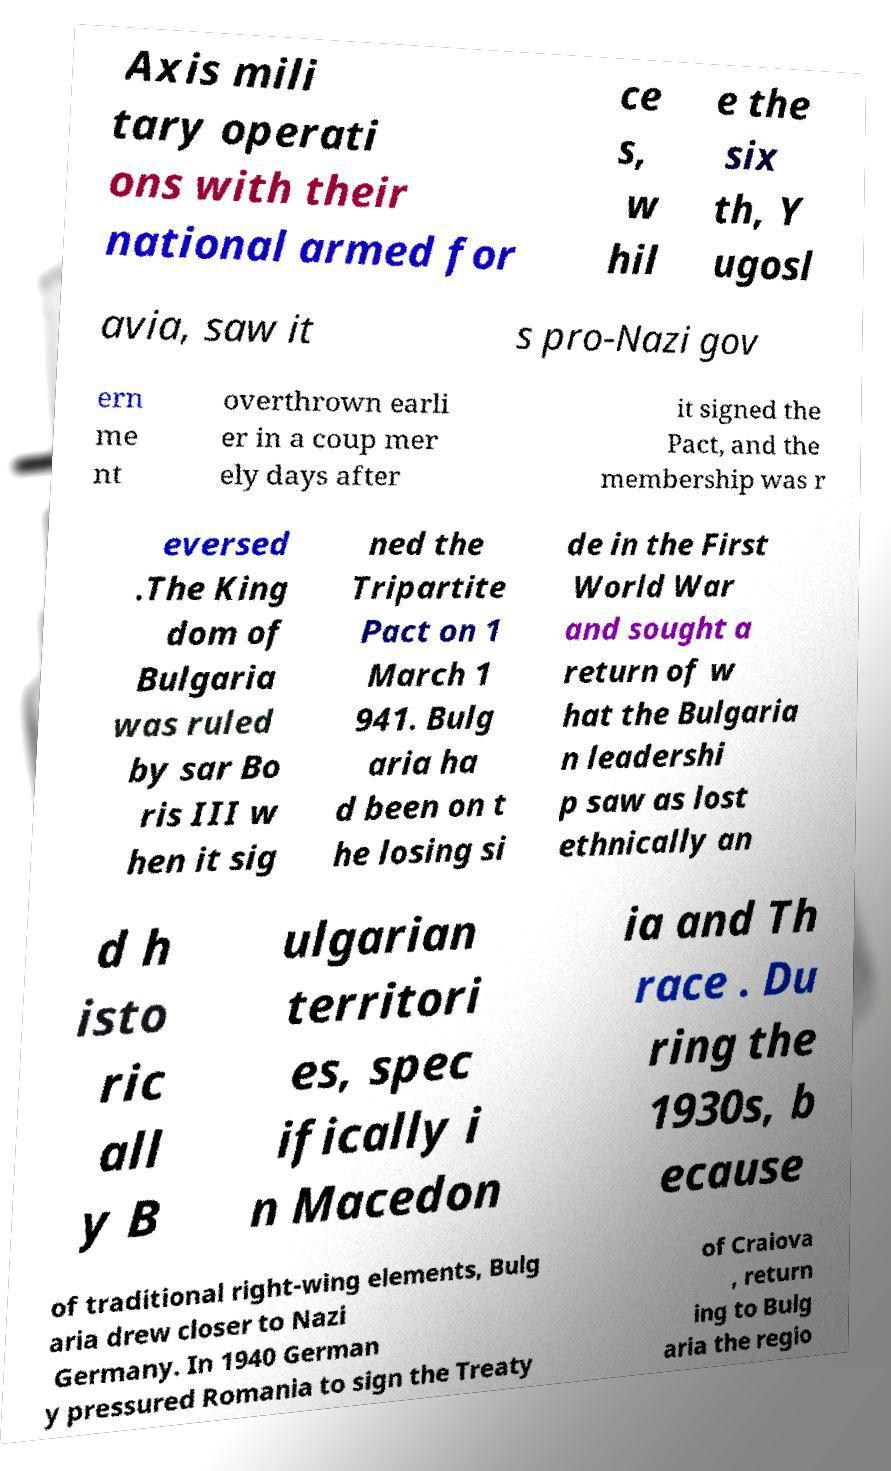Please read and relay the text visible in this image. What does it say? Axis mili tary operati ons with their national armed for ce s, w hil e the six th, Y ugosl avia, saw it s pro-Nazi gov ern me nt overthrown earli er in a coup mer ely days after it signed the Pact, and the membership was r eversed .The King dom of Bulgaria was ruled by sar Bo ris III w hen it sig ned the Tripartite Pact on 1 March 1 941. Bulg aria ha d been on t he losing si de in the First World War and sought a return of w hat the Bulgaria n leadershi p saw as lost ethnically an d h isto ric all y B ulgarian territori es, spec ifically i n Macedon ia and Th race . Du ring the 1930s, b ecause of traditional right-wing elements, Bulg aria drew closer to Nazi Germany. In 1940 German y pressured Romania to sign the Treaty of Craiova , return ing to Bulg aria the regio 